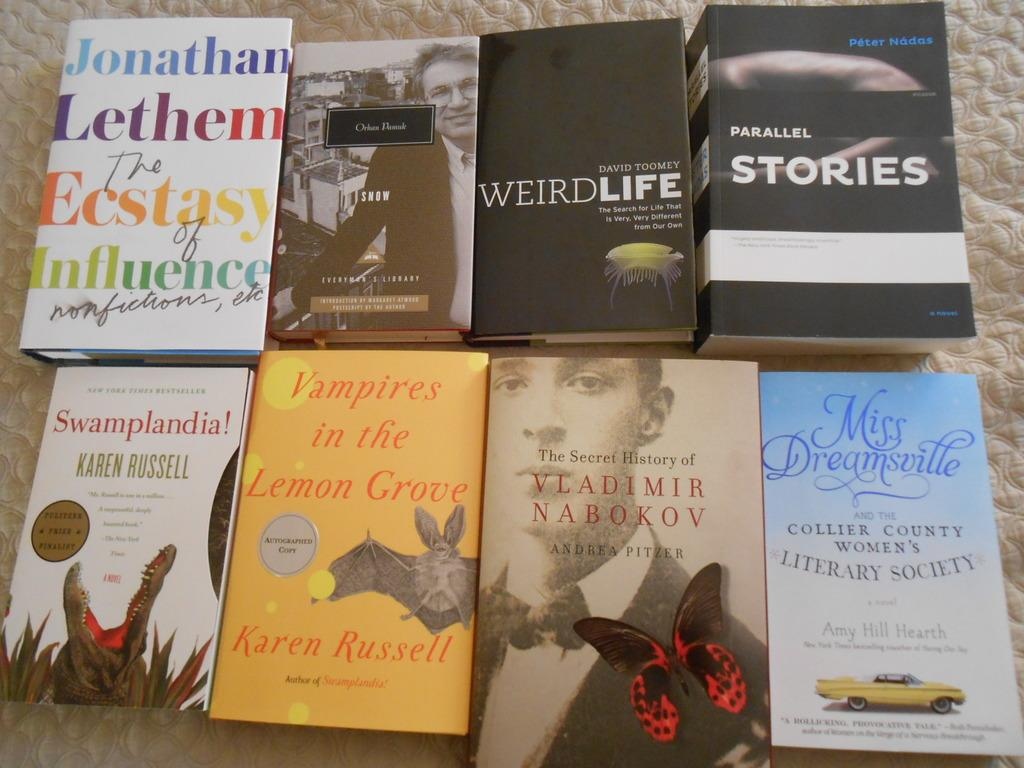<image>
Summarize the visual content of the image. A book called Vampires in the Lemon Grove sits with other books. 